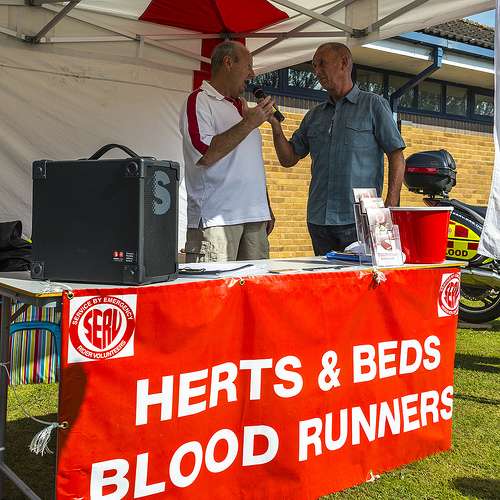<image>
Is there a shirt on the man? No. The shirt is not positioned on the man. They may be near each other, but the shirt is not supported by or resting on top of the man. 